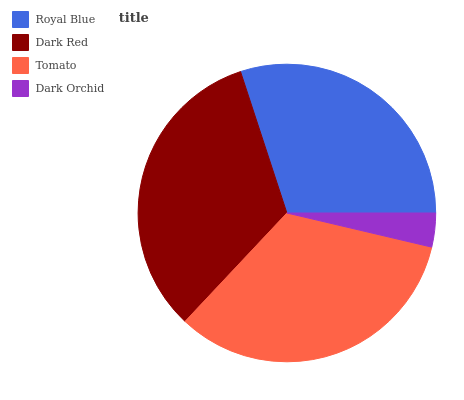Is Dark Orchid the minimum?
Answer yes or no. Yes. Is Tomato the maximum?
Answer yes or no. Yes. Is Dark Red the minimum?
Answer yes or no. No. Is Dark Red the maximum?
Answer yes or no. No. Is Dark Red greater than Royal Blue?
Answer yes or no. Yes. Is Royal Blue less than Dark Red?
Answer yes or no. Yes. Is Royal Blue greater than Dark Red?
Answer yes or no. No. Is Dark Red less than Royal Blue?
Answer yes or no. No. Is Dark Red the high median?
Answer yes or no. Yes. Is Royal Blue the low median?
Answer yes or no. Yes. Is Tomato the high median?
Answer yes or no. No. Is Dark Orchid the low median?
Answer yes or no. No. 